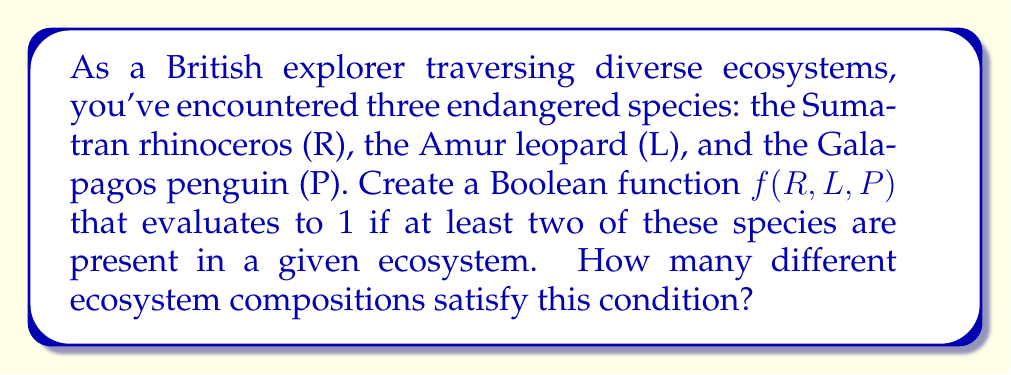Give your solution to this math problem. Let's approach this step-by-step:

1) First, we need to create the Boolean function $f(R,L,P)$ that represents the presence of at least two species:

   $f(R,L,P) = RL + RP + LP$

   This is because we need either R and L, R and P, or L and P to be present.

2) To find how many ecosystem compositions satisfy this condition, we need to count the number of input combinations that make $f(R,L,P) = 1$.

3) We can do this by creating a truth table:

   R | L | P | f(R,L,P)
   0 | 0 | 0 |    0
   0 | 0 | 1 |    0
   0 | 1 | 0 |    0
   0 | 1 | 1 |    1
   1 | 0 | 0 |    0
   1 | 0 | 1 |    1
   1 | 1 | 0 |    1
   1 | 1 | 1 |    1

4) From the truth table, we can see that there are 4 combinations where $f(R,L,P) = 1$.

Therefore, there are 4 different ecosystem compositions that satisfy the condition of having at least two of these endangered species present.
Answer: 4 